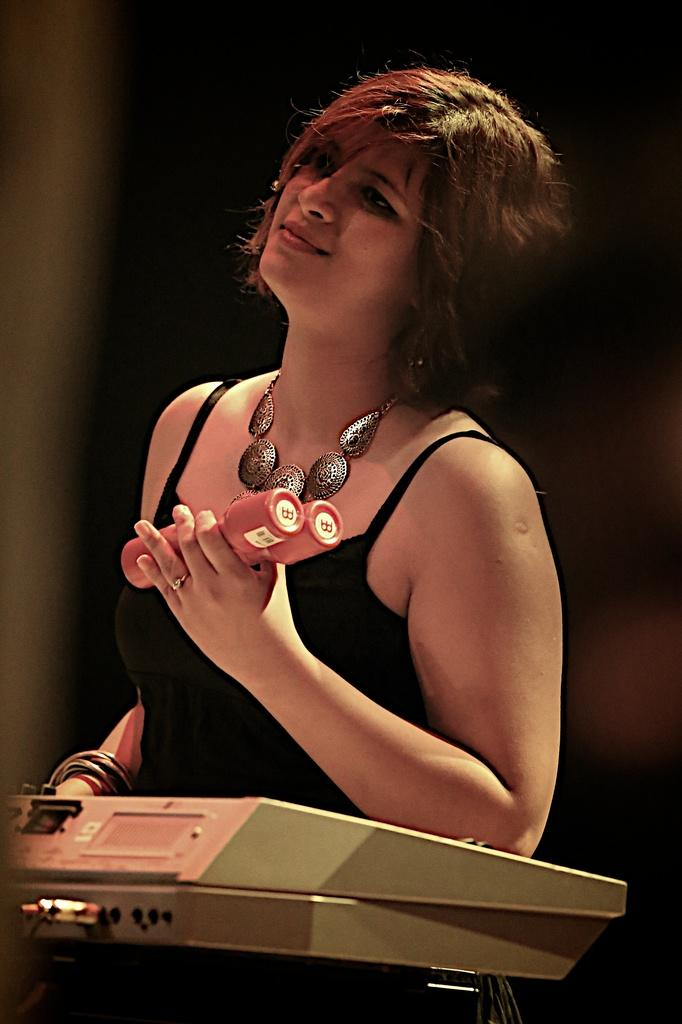Who is the main subject in the image? There is a woman in the image. What is the woman wearing on her upper body? The woman is wearing a black top. What accessory is the woman wearing around her neck? The woman is wearing a necklace. What is the woman holding in her hands? The woman is holding two weights. What device is the woman operating in the image? The woman is operating an amplifier. How would you describe the background of the image? The background of the image is blurry. What is the aftermath of the queen's visit in the image? There is no mention of a queen or any visit in the image, so it is not possible to discuss the aftermath. 